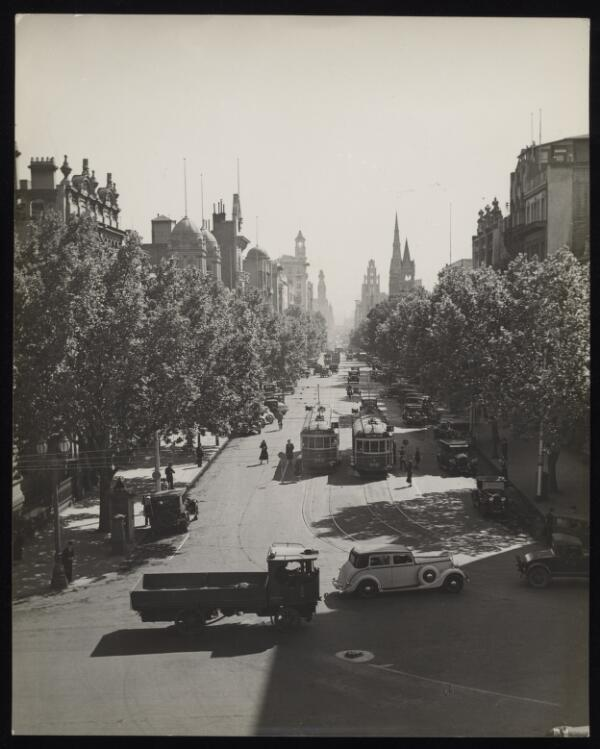Please describe the contents of this image in 5 or 6 sentences so that a person searching for it using text will be able to find it and your generated summary will provide them with an accurate description of the image. Only describe content present in the image. The black-and-white photograph depicts a busy urban street scene with a central road lined with trees on both sides. A few trams are visible traveling down the middle of the street, with pedestrians crossing and walking along the sidewalks. Various vehicles, including a truck and a car, are seen at an intersection in the foreground. The buildings on either side of the street are tall and ornate, with some spires and clock towers visible in the distance, adding to the historic feel of the cityscape. The play of light and shadow indicates that it is a sunny day. The overall atmosphere suggests a bustling city life from a bygone era. 